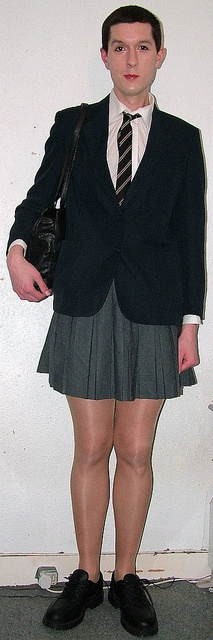Describe the objects in this image and their specific colors. I can see people in lightgray, black, brown, gray, and purple tones, handbag in lightgray, black, gray, salmon, and purple tones, and tie in lightgray, black, gray, and darkgray tones in this image. 